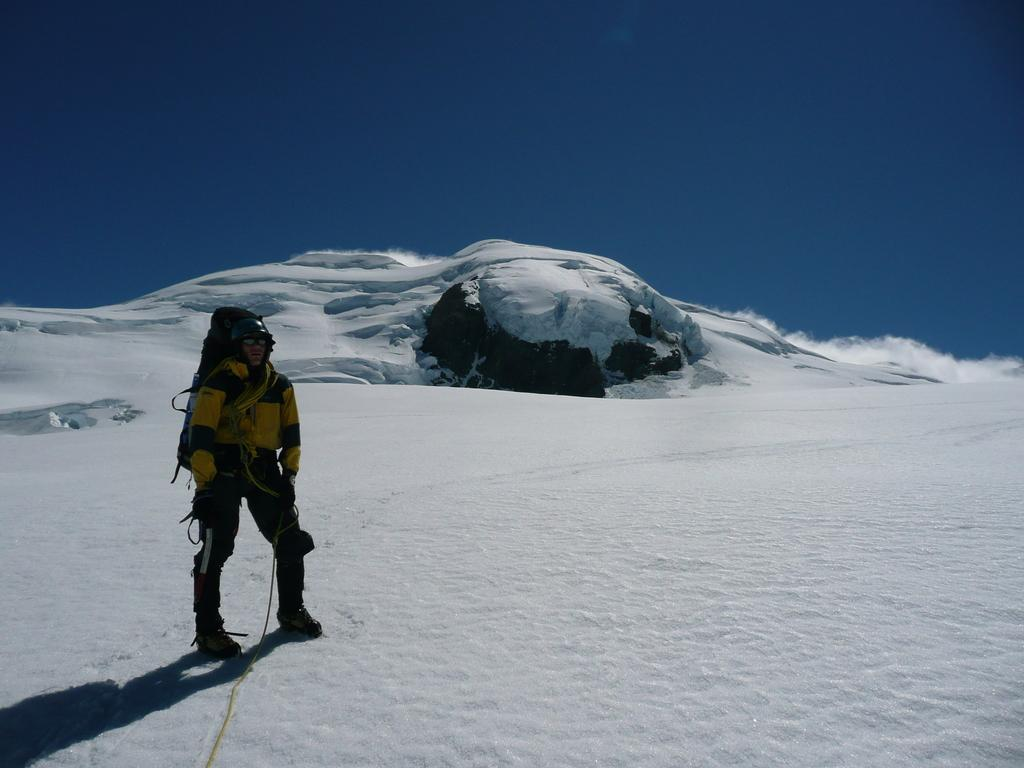Who or what is in the front of the image? There is a person in the front of the image. What is the condition of the land in the image? The land is covered with snow. What can be seen in the background of the image? There is a blue sky in the background of the image. What type of pleasure can be seen being enjoyed by the person in the image? There is no indication of pleasure or any specific activity being enjoyed by the person in the image. 